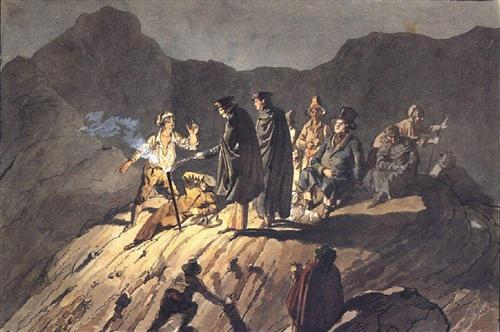Do the characters' clothing styles provide any clues about the time period of this scene? The clothing styles of the characters, marked by dark, almost somber attire and distinctive hats, hint at a historical setting. The long cloaks, heavy fabric, and notable hats could be indicative of fashion from the 18th to early 19th century. Such clothing suggests a time when attire was not only functional for the elements but also a signifier of social status and role within the scene's narrative. 